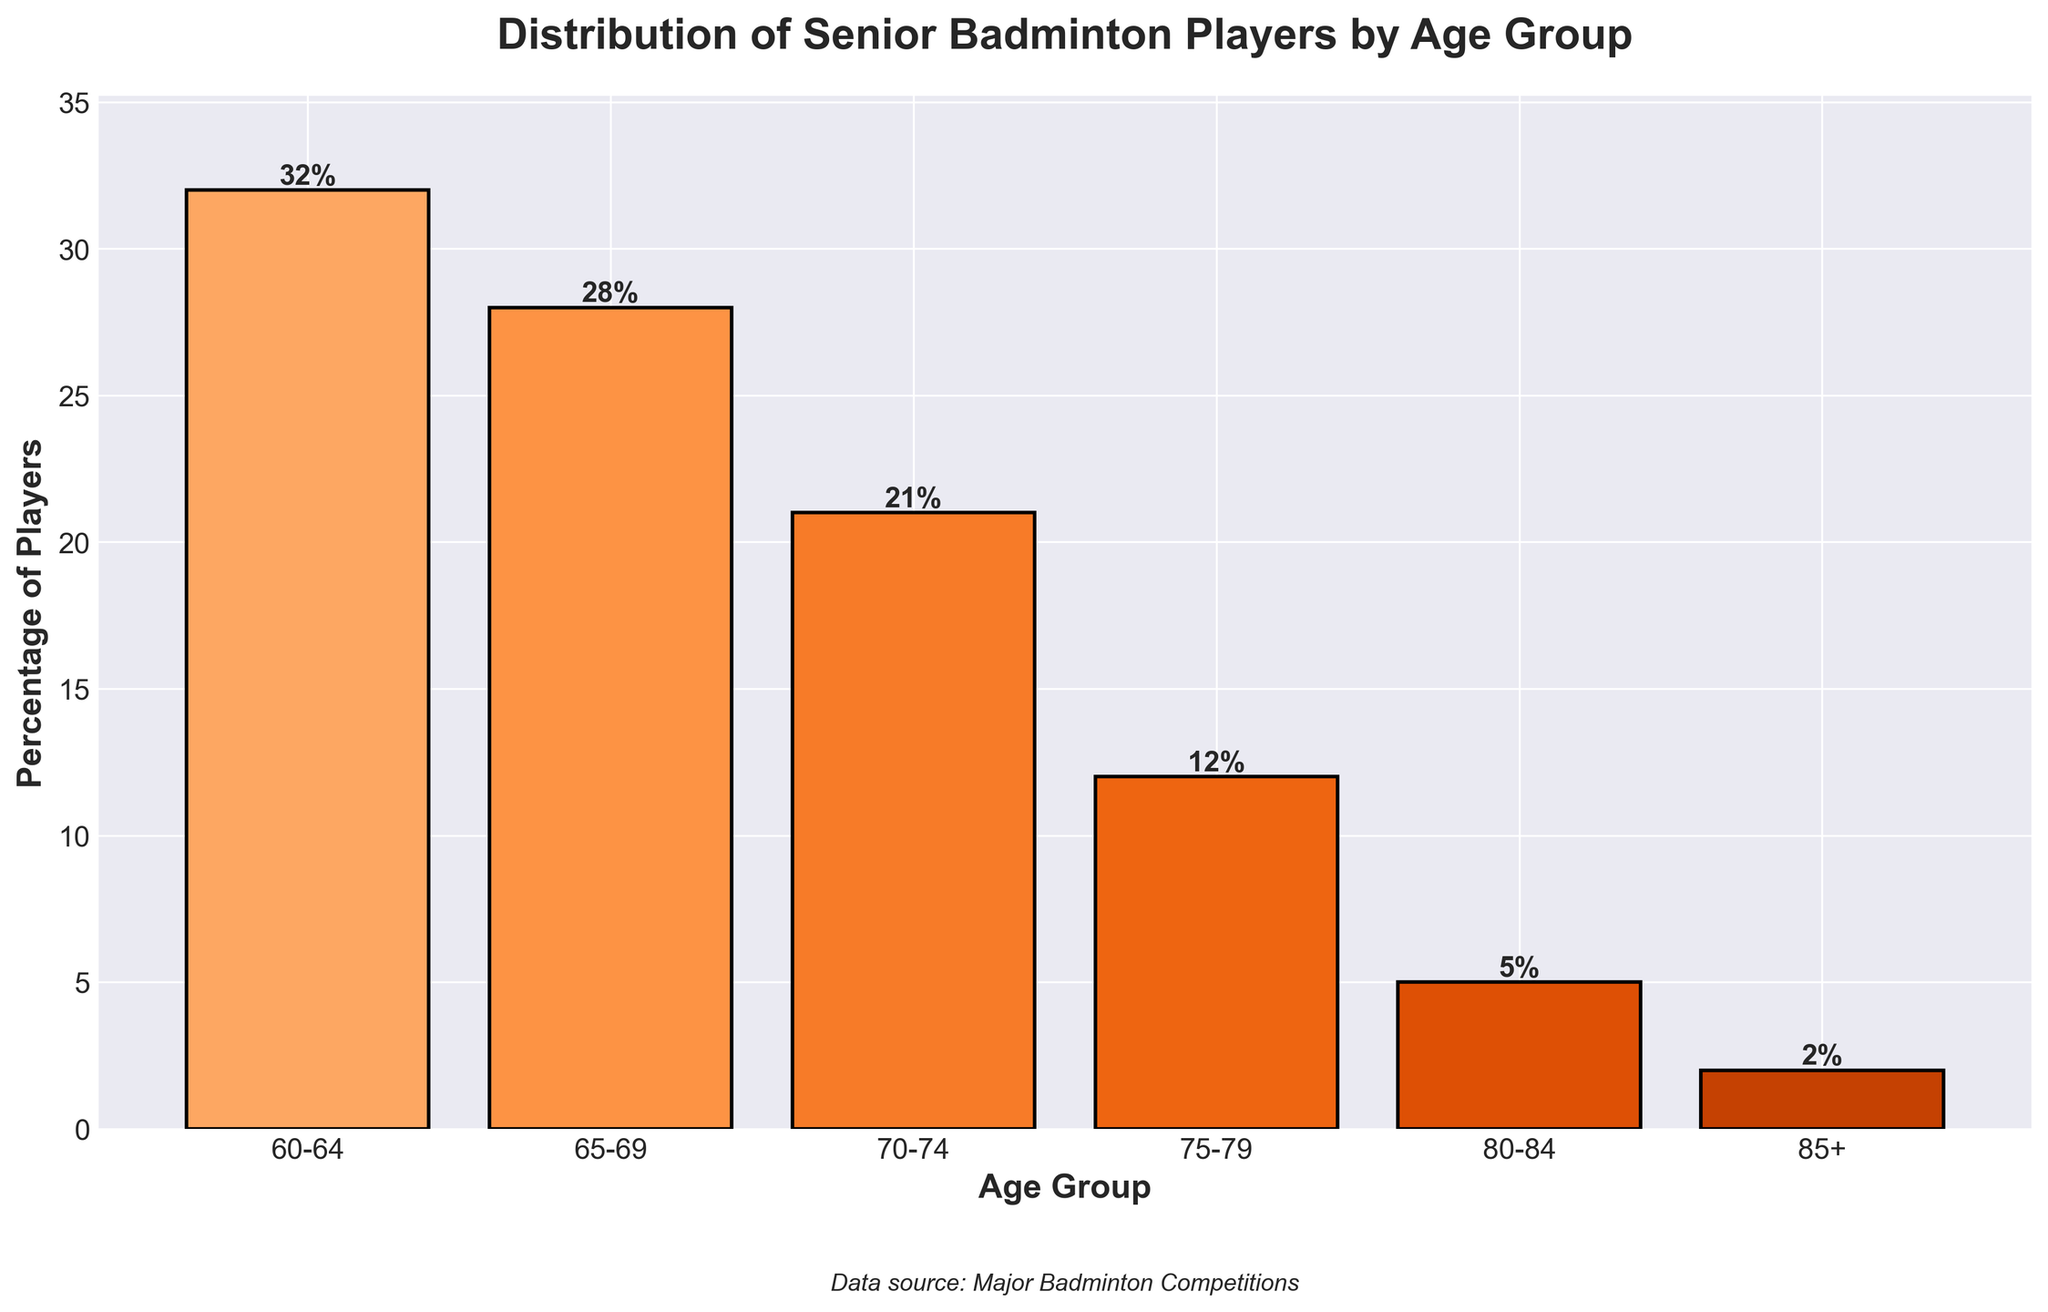Which age group has the highest percentage of players? To find the answer, look at the height of the bars and the percentage values annotated on top of each bar. The tallest bar with the highest percentage value is the 60-64 age group with 32%.
Answer: 60-64 What is the total percentage of players aged 70 and above? To compute the total percentage, sum up the values for the age groups 70-74, 75-79, 80-84, and 85+. The sum is 21% + 12% + 5% + 2% = 40%.
Answer: 40% How does the percentage of players in the 65-69 age group compare to the 75-79 age group? Compare the heights of the bars or the percentage values annotated on top of the 65-69 and 75-79 age groups. The 65-69 age group has 28%, which is greater than the 75-79 age group with 12%.
Answer: 65-69 > 75-79 Which age groups have a percentage of players that is less than 15%? Identify the bars that are less than the 15% mark. The age groups that fit this criterion are 75-79 with 12%, 80-84 with 5%, and 85+ with 2%.
Answer: 75-79, 80-84, 85+ What is the average percentage of players across all age groups? Calculate the average by summing up the percentages for all groups and dividing by the number of groups. Sum = 32 + 28 + 21 + 12 + 5 + 2 = 100. Average = 100 / 6 = 16.67%.
Answer: 16.67% How much larger is the percentage of players in the 60-64 age group compared to the 80-84 age group? Subtract the percentage of the 80-84 age group from the 60-64 age group. The calculation is 32% - 5% = 27%.
Answer: 27% Which age group has the smallest percentage of players, and what is that percentage? Find the shortest bar, which corresponds to the smallest percentage. The 85+ age group has the smallest percentage with 2%.
Answer: 85+, 2% How does the total percentage of players under 70 compare with those 70 and above? Sum the percentages for the age groups under 70 (60-64 and 65-69) and compare with the total for age groups 70 and above (70-74, 75-79, 80-84, 85+). Under 70: 32% + 28% = 60%. 70 and above: 21% + 12% + 5% + 2% = 40%.
Answer: Under 70 > 70+ If you combine the percentages of the 70-74 and 75-79 age groups, how does it compare to the 65-69 age group? Sum the percentages of the 70-74 and 75-79 age groups and compare to the 65-69 age group. 21% + 12% = 33%, which is greater than 28% of the 65-69 age group.
Answer: 70-74 & 75-79 > 65-69 